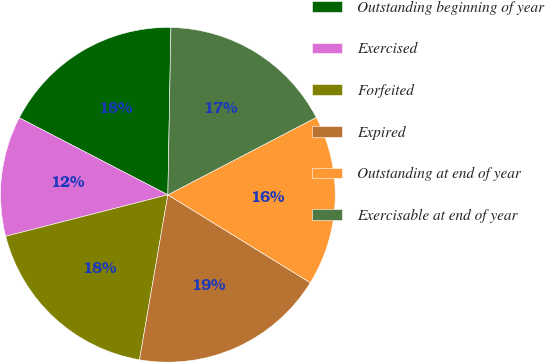<chart> <loc_0><loc_0><loc_500><loc_500><pie_chart><fcel>Outstanding beginning of year<fcel>Exercised<fcel>Forfeited<fcel>Expired<fcel>Outstanding at end of year<fcel>Exercisable at end of year<nl><fcel>17.68%<fcel>11.6%<fcel>18.3%<fcel>18.91%<fcel>16.45%<fcel>17.06%<nl></chart> 